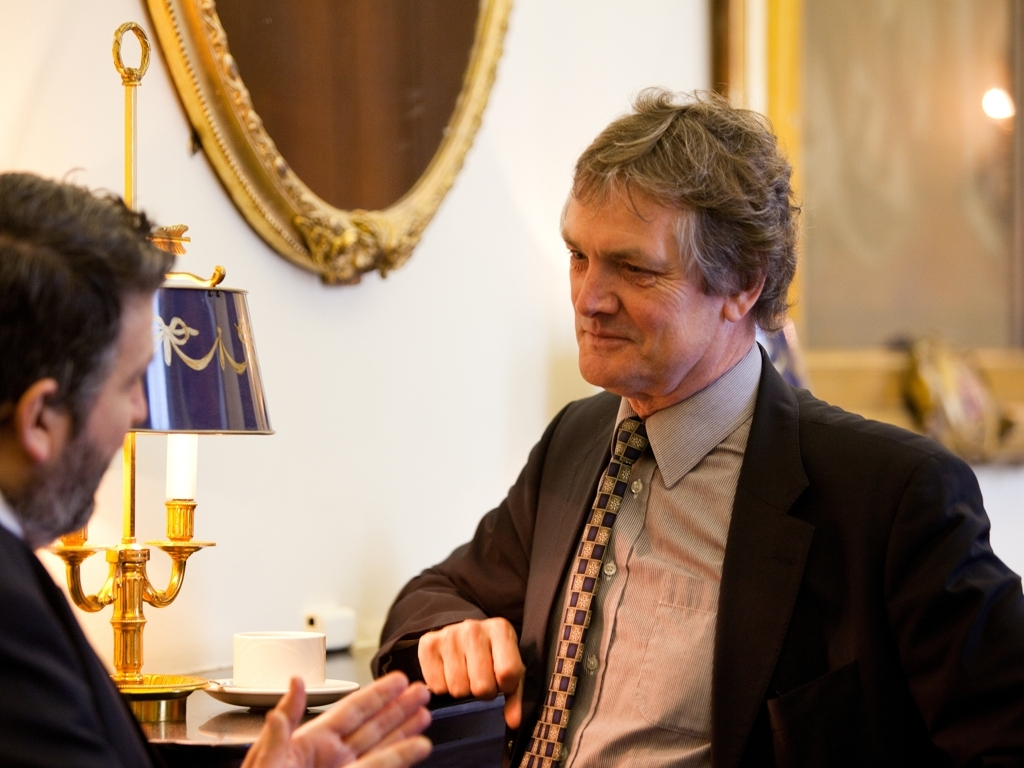Can you describe the setting this conversation is taking place in? The setting is a classically styled room, possibly within a formal or traditional institution such as a government office, legal firm, or a luxury hotel. The decor includes a prominent golden chandelier lamp on the table, adding sophistication to the environment. The stately framed painting hung on the wall further contributes to the dignified and elegant atmosphere suitable for serious conversations. 